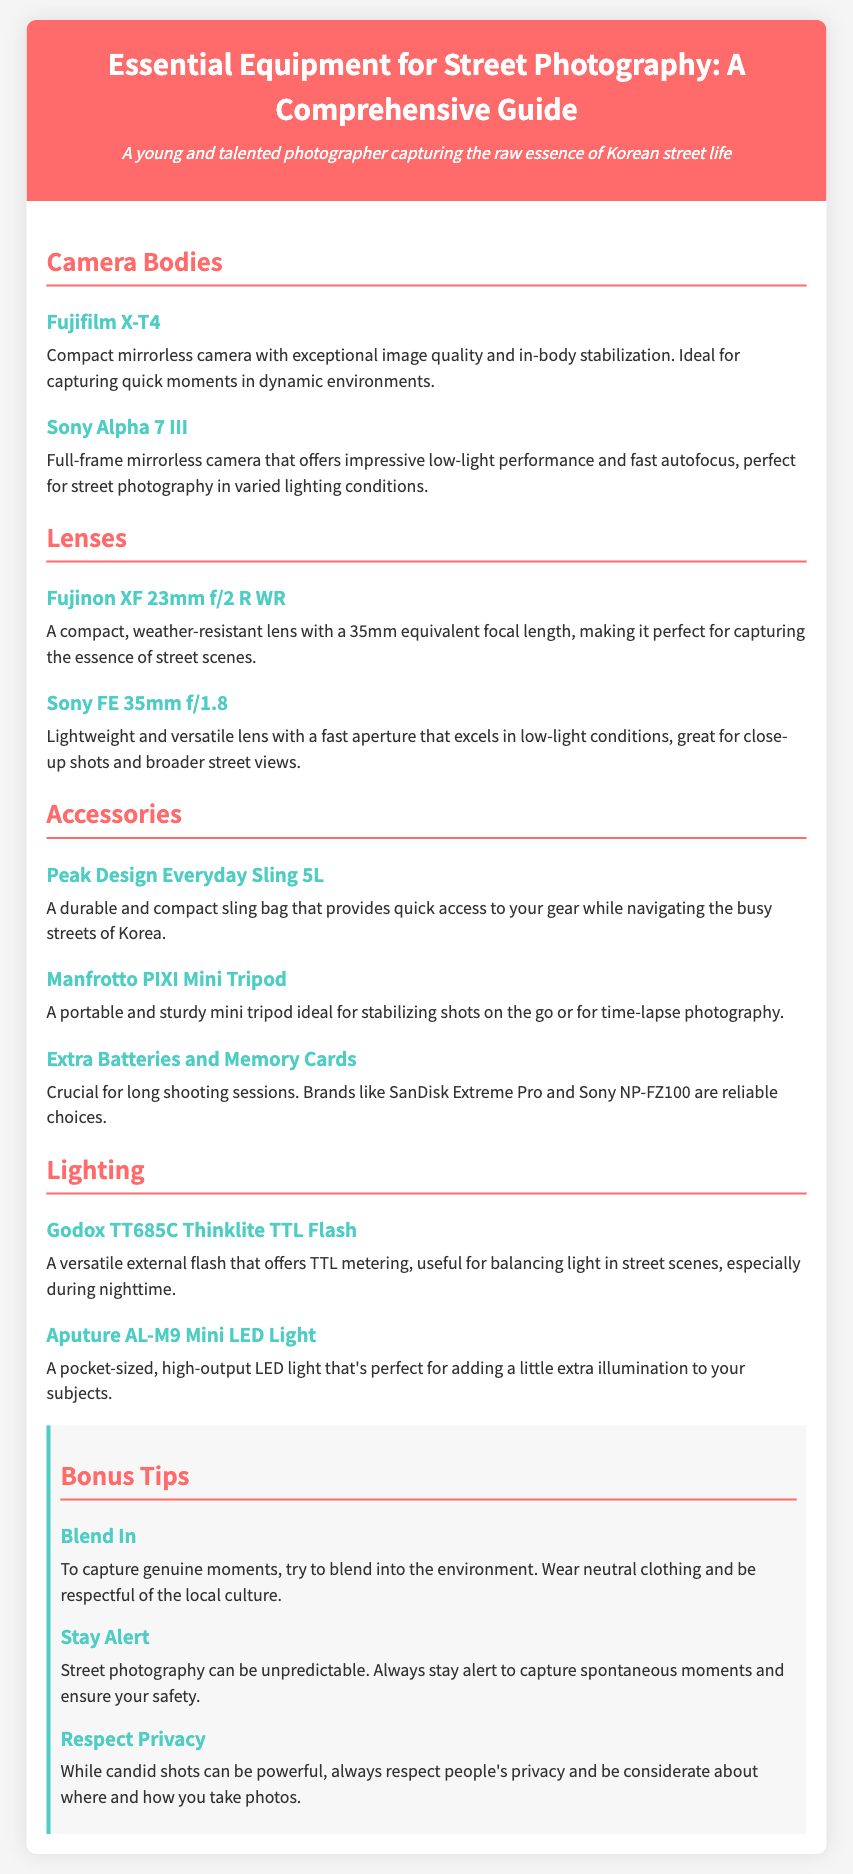What is the first camera listed? The first camera mentioned in the document is Fujifilm X-T4, which is a compact mirrorless camera.
Answer: Fujifilm X-T4 What focal length does the Fujinon XF 23mm f/2 R WR lens have? The Fujinon XF 23mm f/2 R WR lens has a 35mm equivalent focal length, suitable for street scenes.
Answer: 35mm Which accessory is described as a "durable and compact sling bag"? The document describes the Peak Design Everyday Sling 5L as a durable and compact sling bag for quick access to gear.
Answer: Peak Design Everyday Sling 5L What type of light does the Aputure AL-M9 provide? The Aputure AL-M9 is a pocket-sized, high-output LED light that adds extra illumination.
Answer: LED light Why should photographers blend in according to the tips? The tip advises photographers to blend in to capture genuine moments and respect local culture.
Answer: Capture genuine moments What is the function of the Godox TT685C Thinklite TTL Flash? The Godox TT685C Thinklite TTL Flash offers TTL metering, useful for balancing light in street scenes, especially at night.
Answer: TTL metering What is the brand of the semi-compact lens that excels in low-light? The lens mentioned as excelling in low-light conditions is from Sony, specifically the Sony FE 35mm f/1.8.
Answer: Sony What should photographers do to ensure safety according to the bonus tips? The document advises staying alert to capture spontaneous moments and ensure safety during street photography.
Answer: Stay alert 